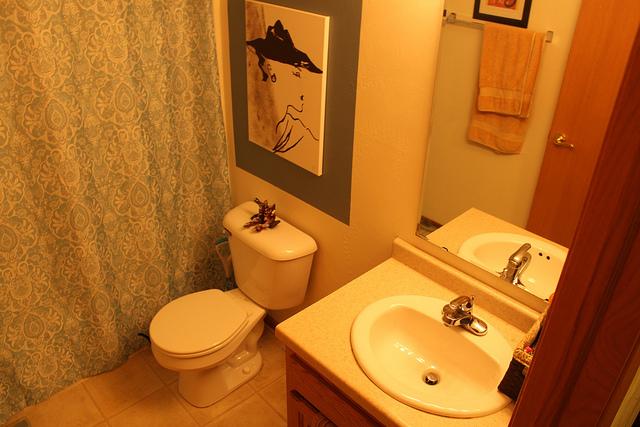Is the sink clean?
Quick response, please. Yes. Would this be considered a spacious bathroom?
Concise answer only. No. What can be seen in the mirror?
Concise answer only. Towel. 